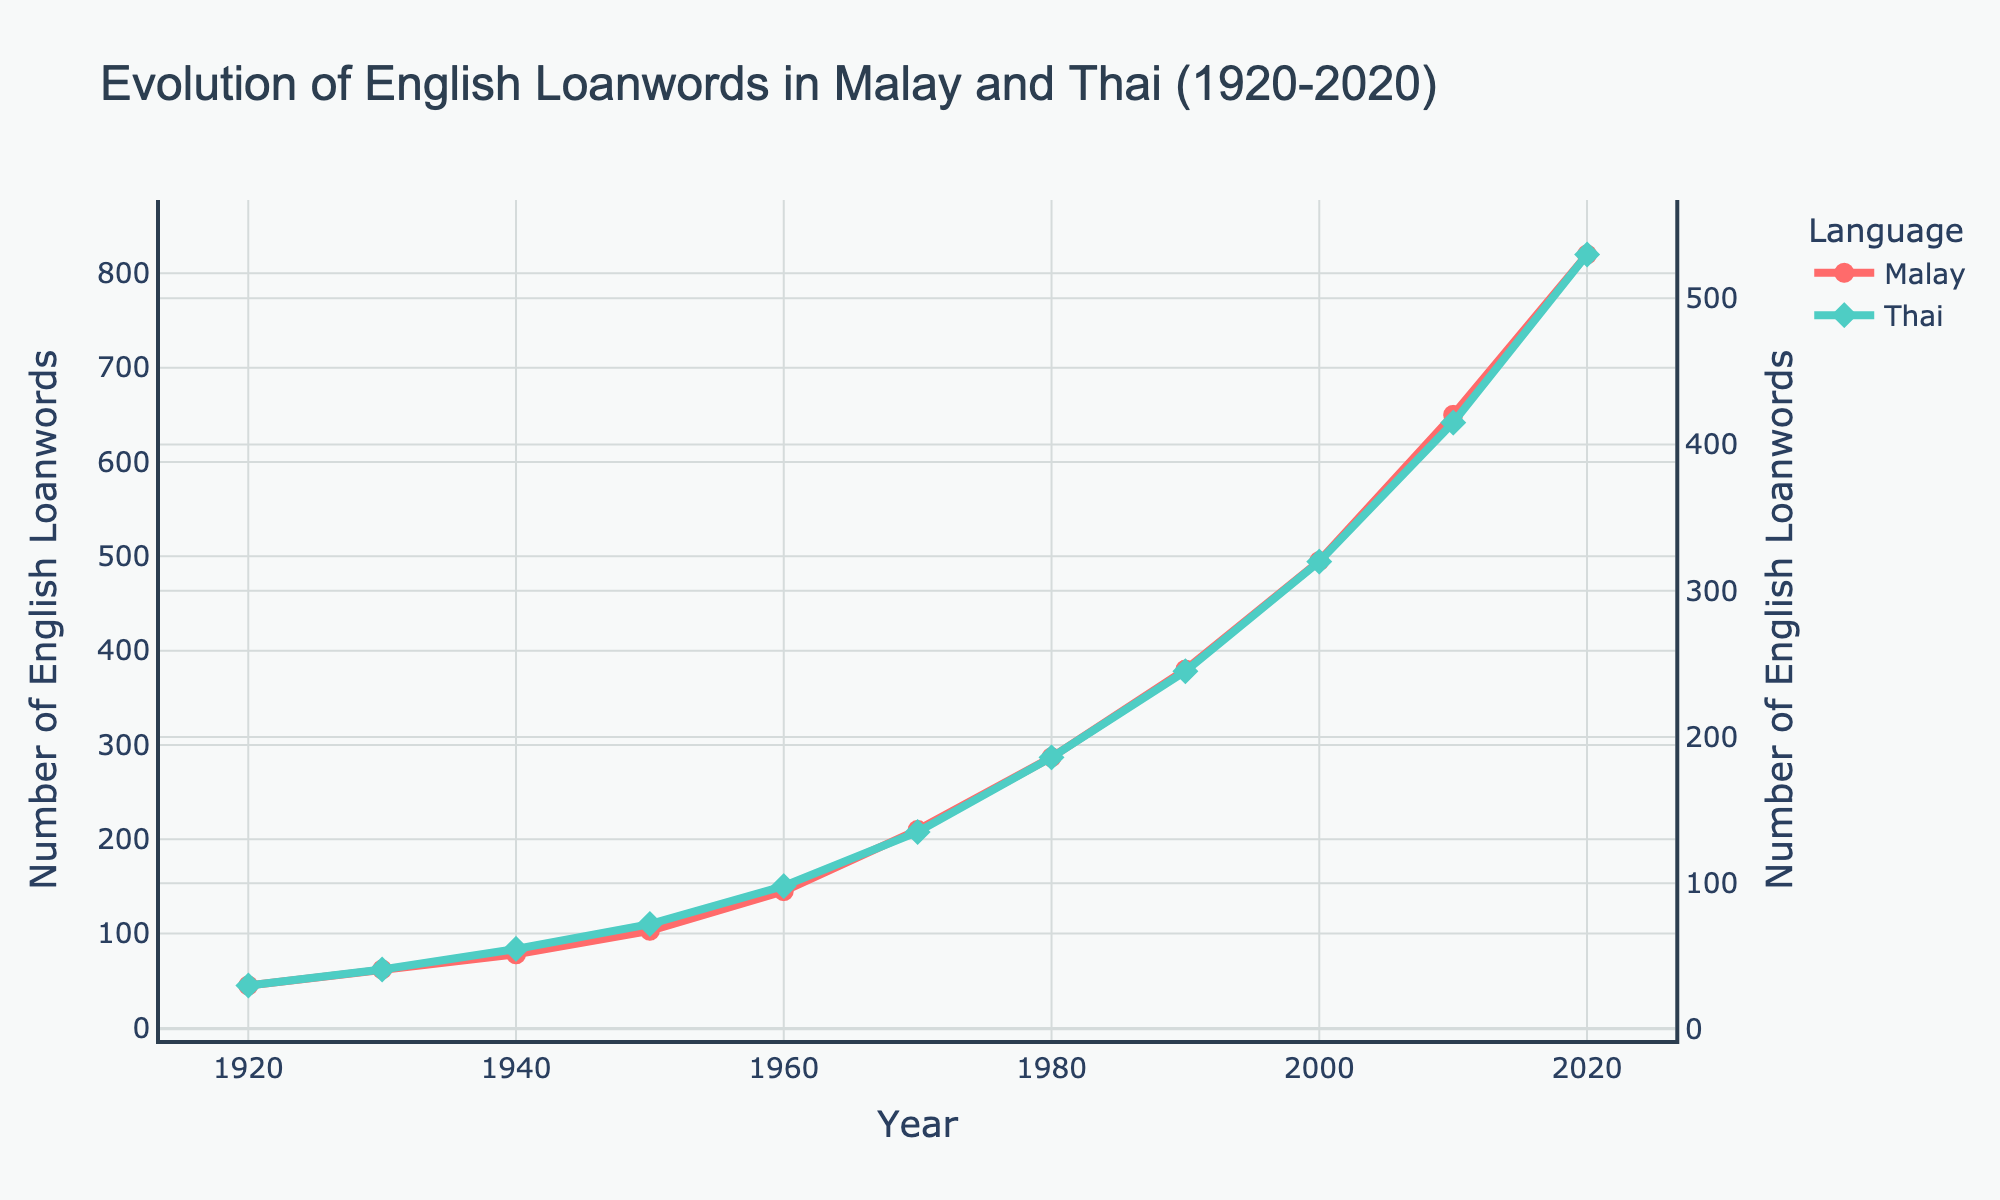What's the difference in the number of English loanwords in Malay and Thai in 2020? To find the difference, look at the values for 2020. In 2020, Malay has 820 English loanwords and Thai has 530. The difference is 820 - 530.
Answer: 290 In which year did Thai have more than double the number of English loanwords compared to 1930? First, find the number of English loanwords in Thai in 1930, which is 41. Double this value is 82. Look for the first year after 1930 where the number exceeds 82. In 1960, Thai has 98 English loanwords, which is more than double 41.
Answer: 1960 What is the average number of English loanwords in Malay across the decades shown? Sum the values for Malay and divide by the number of decades (11): (45 + 62 + 78 + 103 + 145 + 210 + 287 + 380 + 495 + 650 + 820) / 11. The sum is 3275. The average is 3275 / 11.
Answer: 297.73 By how much did the number of English loanwords in Malay increase from 1950 to 1970? Look at the values for Malay in 1950 and 1970. In 1950, it is 103, and in 1970, it is 210. The increase is 210 - 103.
Answer: 107 Which year marks the highest increase in English loanwords for either language compared to the previous decade? To find the highest increase, calculate the decade-over-decade difference for both languages. For Malay: (from 1920-1930: 17, 1930-1940: 16, 1940-1950: 25, 1950-1960: 42, 1960-1970: 65, 1970-1980: 77, 1980-1990: 93, 1990-2000: 115, 2000-2010: 155, 2010-2020: 170). For Thai: (from 1920-1930: 11, 1930-1940: 14, 1940-1950: 17, 1950-1960: 26, 1960-1970: 37, 1970-1980: 51, 1980-1990: 59, 1990-2000: 75, 2000-2010: 95, 2010-2020: 115). The highest increase is from 2000-2010 for Malay, with an increase of 170.
Answer: 2000-2010 Which language had more English loanwords in 1970 and by how much? In 1970, Malay had 210 loanwords and Thai had 135. The difference is 210 - 135. So Malay had more, and the difference is 75.
Answer: Malay, 75 Approximately how many times more English loanwords were in Malay compared to Thai in 2010? In 2010, Malay has 650 loanwords and Thai has 415. To approximate the ratio, divide 650 by 415. This is approximately 1.57.
Answer: 1.57 times Between which consecutive decades did Thai see the smallest increase in English loanwords? Calculate the increases per decade for Thai: (1930-1940: 11, 1940-1950: 14, 1950-1960: 17, 1960-1970: 37, 1970-1980: 51, 1980-1990: 59, 1990-2000: 75, 2000-2010: 95, 2010-2020: 115). The smallest increase is from 1930-1940 with an increase of 11.
Answer: 1930-1940 What trend is observed in the number of English loanwords in both Malay and Thai from 1920 to 2020? Observing the data from 1920 to 2020, there is a consistent upward trend in the number of English loanwords in both languages, indicating a steady increase over the century.
Answer: Upward trend 